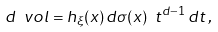Convert formula to latex. <formula><loc_0><loc_0><loc_500><loc_500>d \ v o l = h _ { \xi } ( x ) \, d \sigma ( x ) \ t ^ { d - 1 } \, d t \, ,</formula> 